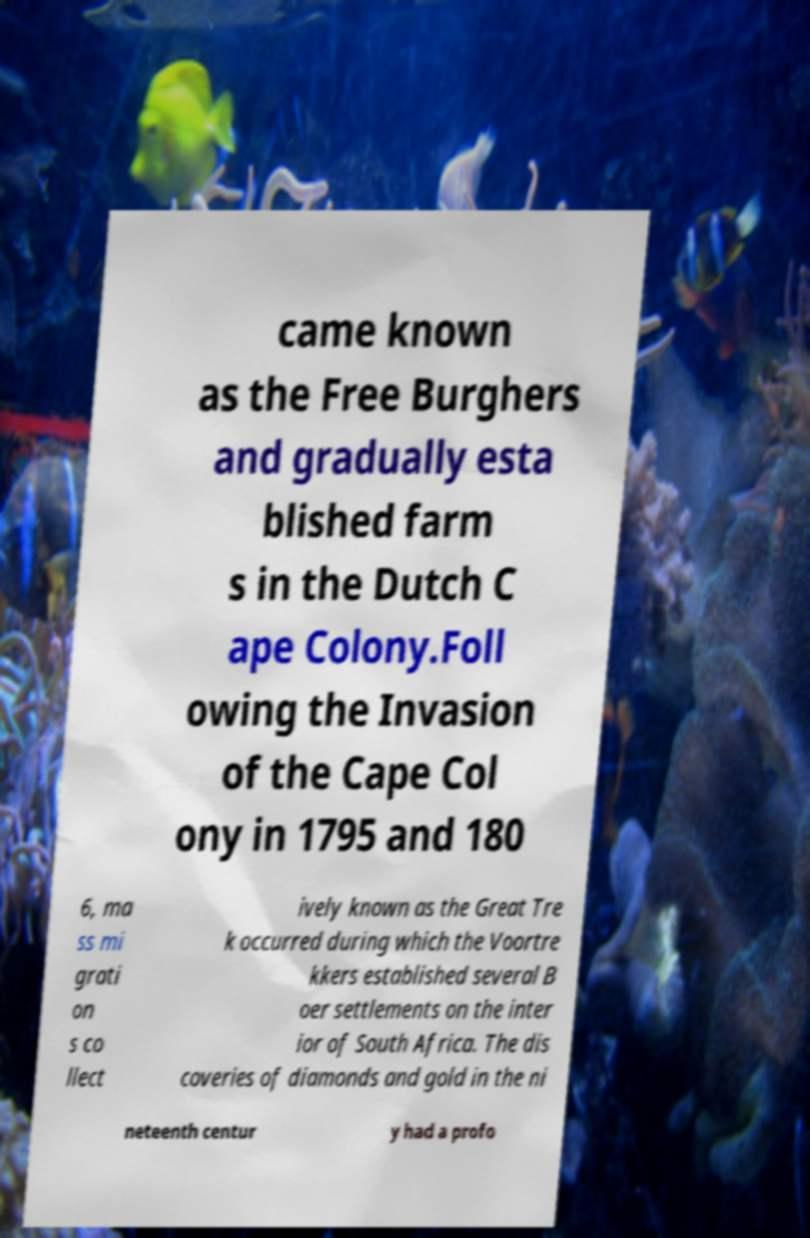Please identify and transcribe the text found in this image. came known as the Free Burghers and gradually esta blished farm s in the Dutch C ape Colony.Foll owing the Invasion of the Cape Col ony in 1795 and 180 6, ma ss mi grati on s co llect ively known as the Great Tre k occurred during which the Voortre kkers established several B oer settlements on the inter ior of South Africa. The dis coveries of diamonds and gold in the ni neteenth centur y had a profo 